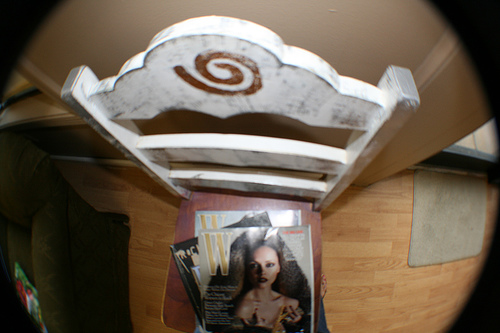<image>
Is there a woman on the chair? Yes. Looking at the image, I can see the woman is positioned on top of the chair, with the chair providing support. Is the magzine in front of the chair? No. The magzine is not in front of the chair. The spatial positioning shows a different relationship between these objects. 